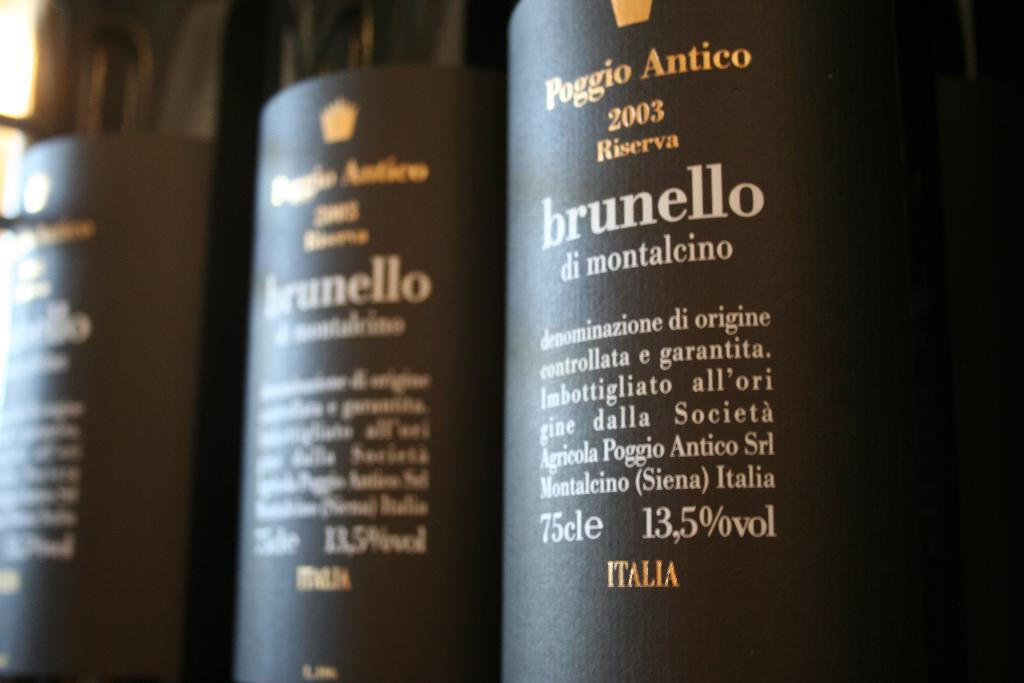<image>
Render a clear and concise summary of the photo. A row of bottles of Poggio Antico wine on a store shelf 